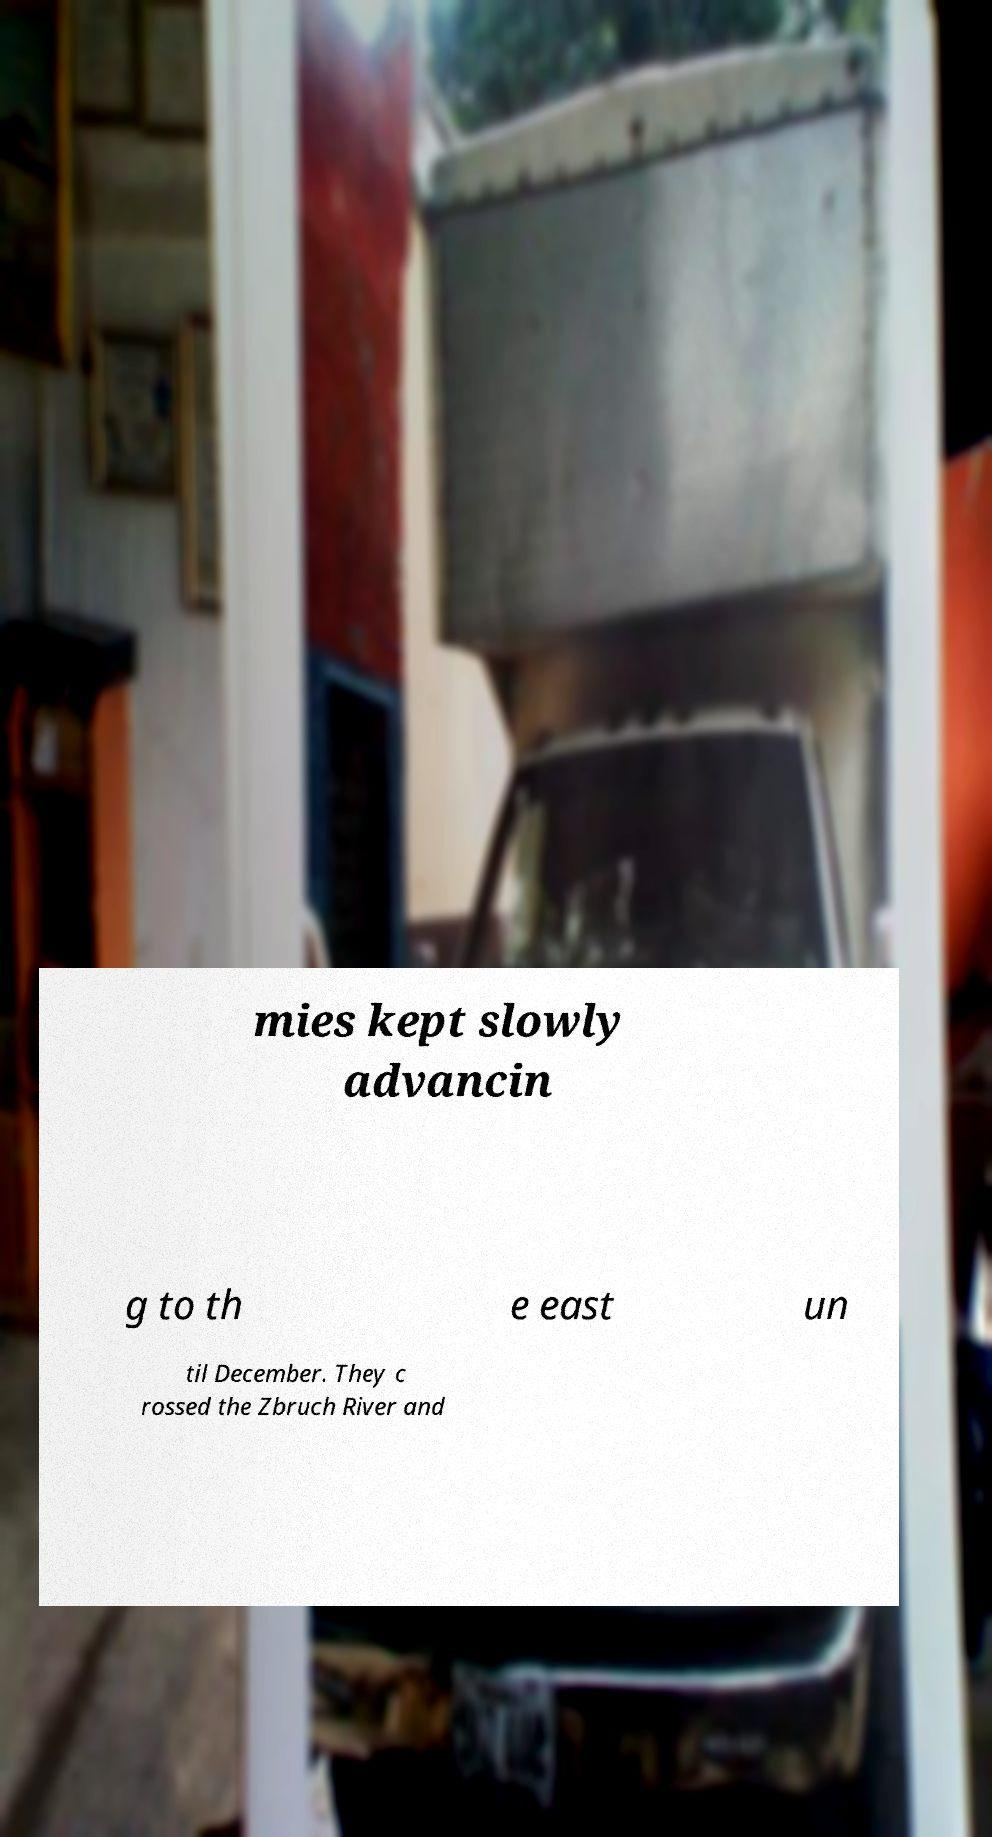Could you assist in decoding the text presented in this image and type it out clearly? mies kept slowly advancin g to th e east un til December. They c rossed the Zbruch River and 